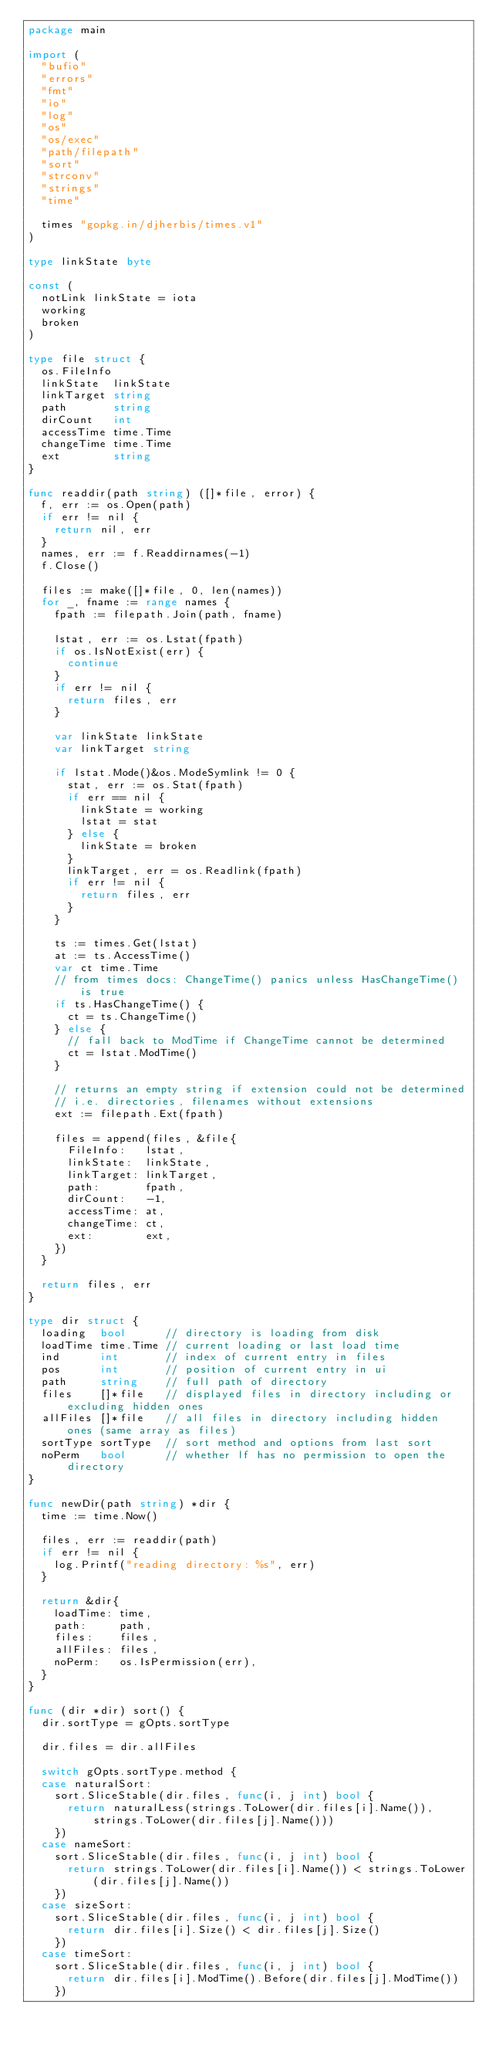<code> <loc_0><loc_0><loc_500><loc_500><_Go_>package main

import (
	"bufio"
	"errors"
	"fmt"
	"io"
	"log"
	"os"
	"os/exec"
	"path/filepath"
	"sort"
	"strconv"
	"strings"
	"time"

	times "gopkg.in/djherbis/times.v1"
)

type linkState byte

const (
	notLink linkState = iota
	working
	broken
)

type file struct {
	os.FileInfo
	linkState  linkState
	linkTarget string
	path       string
	dirCount   int
	accessTime time.Time
	changeTime time.Time
	ext        string
}

func readdir(path string) ([]*file, error) {
	f, err := os.Open(path)
	if err != nil {
		return nil, err
	}
	names, err := f.Readdirnames(-1)
	f.Close()

	files := make([]*file, 0, len(names))
	for _, fname := range names {
		fpath := filepath.Join(path, fname)

		lstat, err := os.Lstat(fpath)
		if os.IsNotExist(err) {
			continue
		}
		if err != nil {
			return files, err
		}

		var linkState linkState
		var linkTarget string

		if lstat.Mode()&os.ModeSymlink != 0 {
			stat, err := os.Stat(fpath)
			if err == nil {
				linkState = working
				lstat = stat
			} else {
				linkState = broken
			}
			linkTarget, err = os.Readlink(fpath)
			if err != nil {
				return files, err
			}
		}

		ts := times.Get(lstat)
		at := ts.AccessTime()
		var ct time.Time
		// from times docs: ChangeTime() panics unless HasChangeTime() is true
		if ts.HasChangeTime() {
			ct = ts.ChangeTime()
		} else {
			// fall back to ModTime if ChangeTime cannot be determined
			ct = lstat.ModTime()
		}

		// returns an empty string if extension could not be determined
		// i.e. directories, filenames without extensions
		ext := filepath.Ext(fpath)

		files = append(files, &file{
			FileInfo:   lstat,
			linkState:  linkState,
			linkTarget: linkTarget,
			path:       fpath,
			dirCount:   -1,
			accessTime: at,
			changeTime: ct,
			ext:        ext,
		})
	}

	return files, err
}

type dir struct {
	loading  bool      // directory is loading from disk
	loadTime time.Time // current loading or last load time
	ind      int       // index of current entry in files
	pos      int       // position of current entry in ui
	path     string    // full path of directory
	files    []*file   // displayed files in directory including or excluding hidden ones
	allFiles []*file   // all files in directory including hidden ones (same array as files)
	sortType sortType  // sort method and options from last sort
	noPerm   bool      // whether lf has no permission to open the directory
}

func newDir(path string) *dir {
	time := time.Now()

	files, err := readdir(path)
	if err != nil {
		log.Printf("reading directory: %s", err)
	}

	return &dir{
		loadTime: time,
		path:     path,
		files:    files,
		allFiles: files,
		noPerm:   os.IsPermission(err),
	}
}

func (dir *dir) sort() {
	dir.sortType = gOpts.sortType

	dir.files = dir.allFiles

	switch gOpts.sortType.method {
	case naturalSort:
		sort.SliceStable(dir.files, func(i, j int) bool {
			return naturalLess(strings.ToLower(dir.files[i].Name()), strings.ToLower(dir.files[j].Name()))
		})
	case nameSort:
		sort.SliceStable(dir.files, func(i, j int) bool {
			return strings.ToLower(dir.files[i].Name()) < strings.ToLower(dir.files[j].Name())
		})
	case sizeSort:
		sort.SliceStable(dir.files, func(i, j int) bool {
			return dir.files[i].Size() < dir.files[j].Size()
		})
	case timeSort:
		sort.SliceStable(dir.files, func(i, j int) bool {
			return dir.files[i].ModTime().Before(dir.files[j].ModTime())
		})</code> 